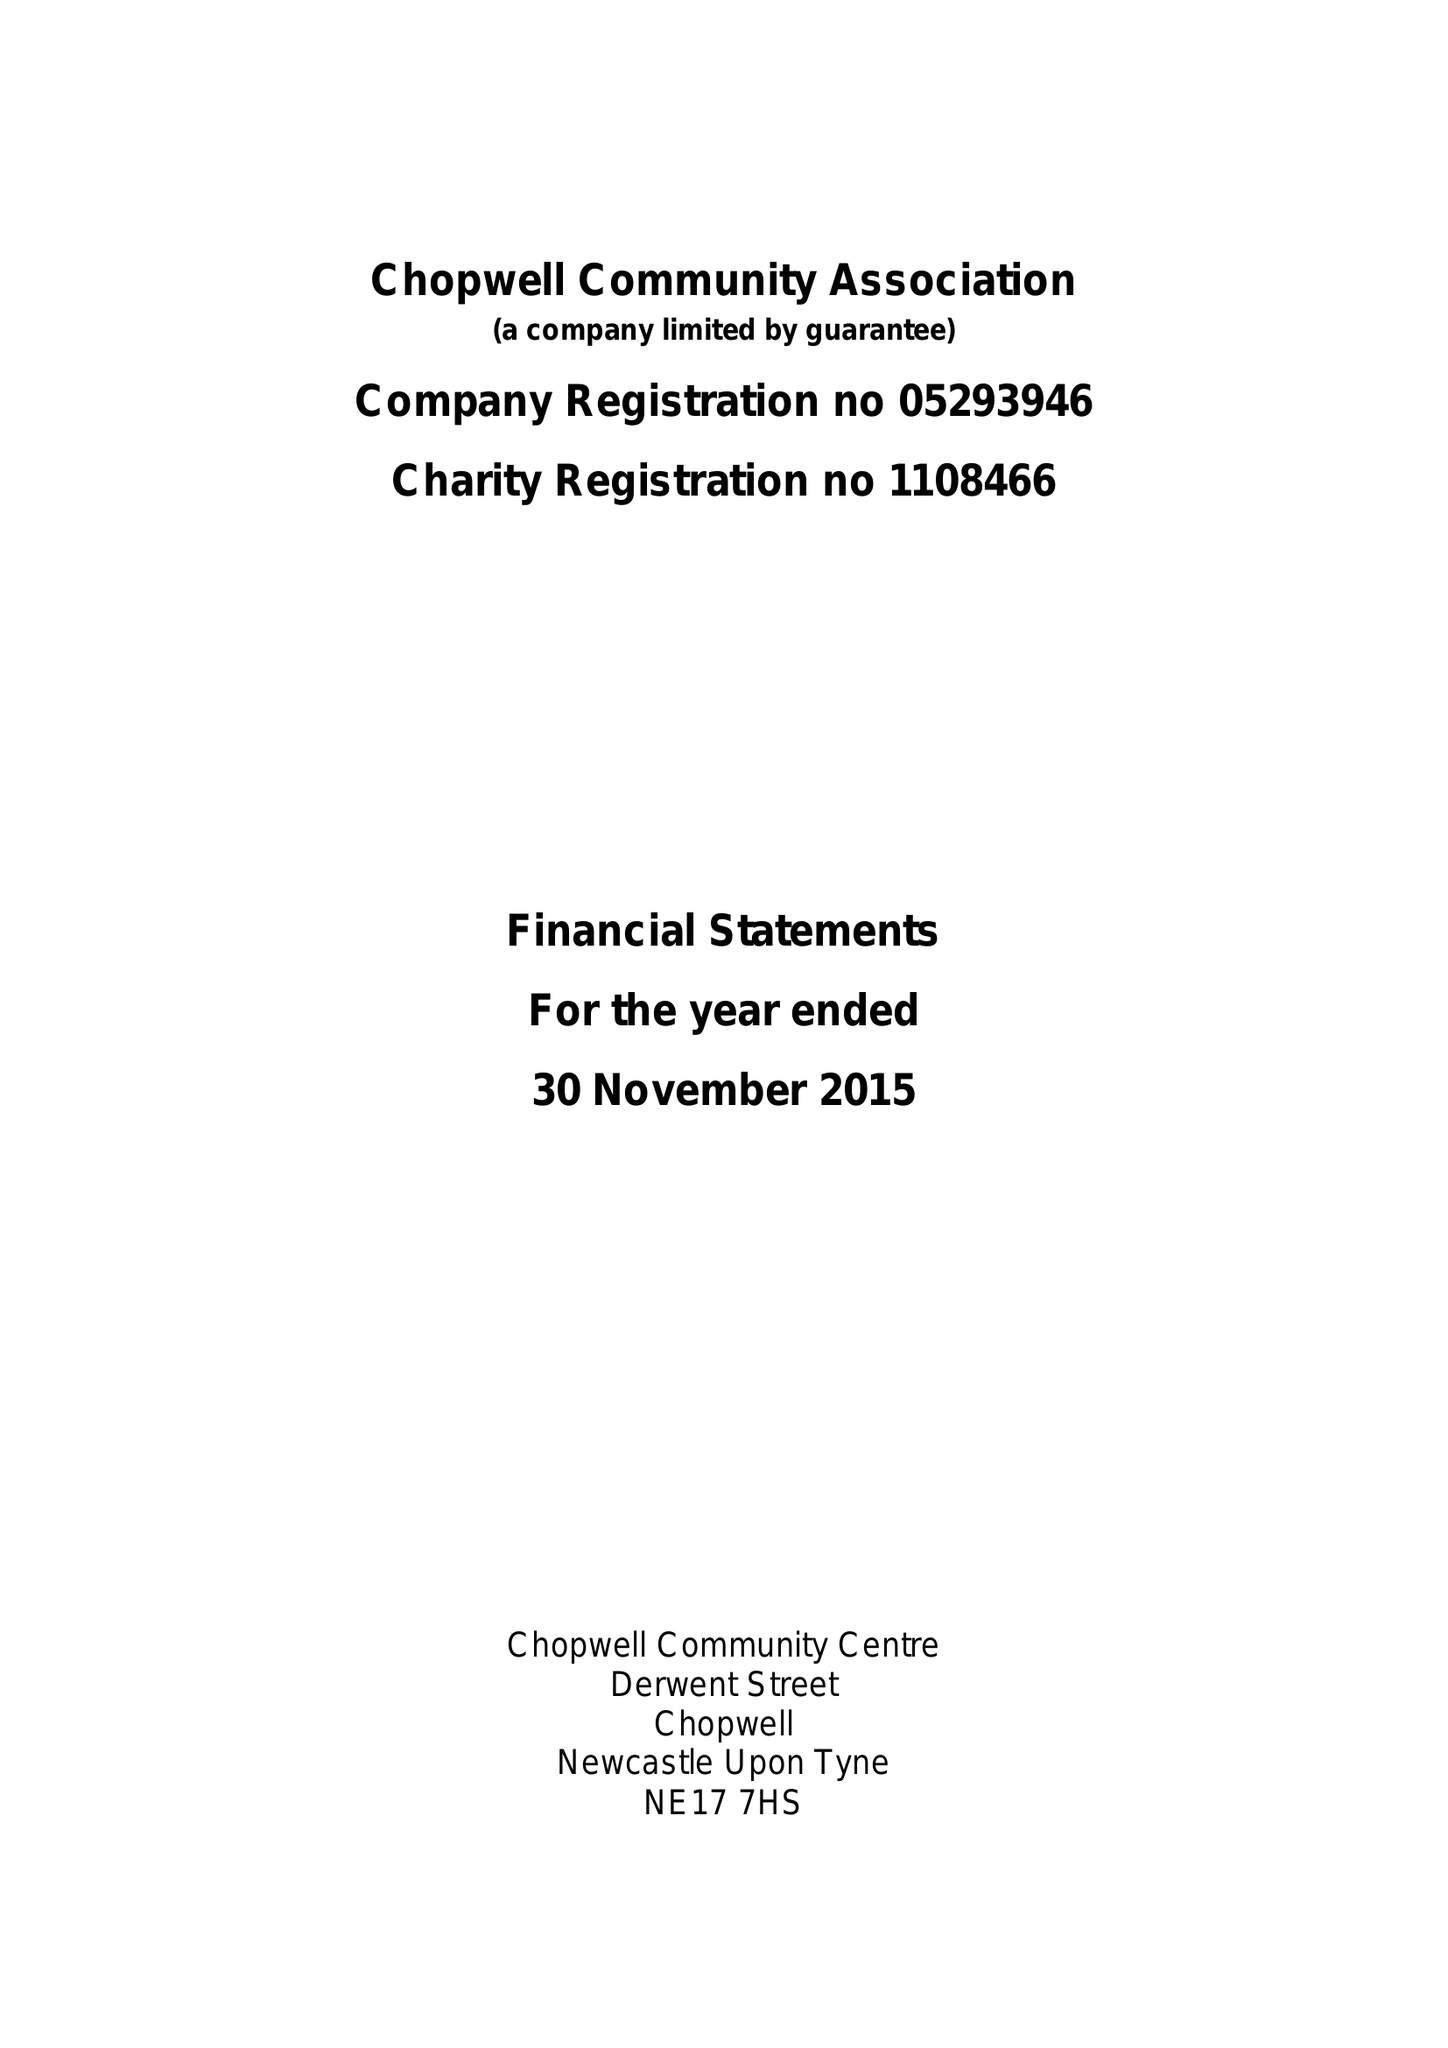What is the value for the spending_annually_in_british_pounds?
Answer the question using a single word or phrase. 45752.00 